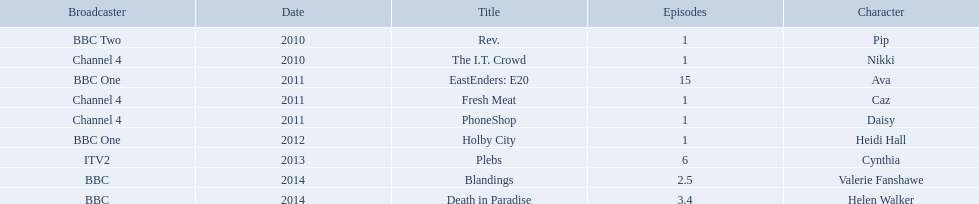Which characters were featured in more then one episode? Ava, Cynthia, Valerie Fanshawe, Helen Walker. Which of these were not in 2014? Ava, Cynthia. Which one of those was not on a bbc broadcaster? Cynthia. 